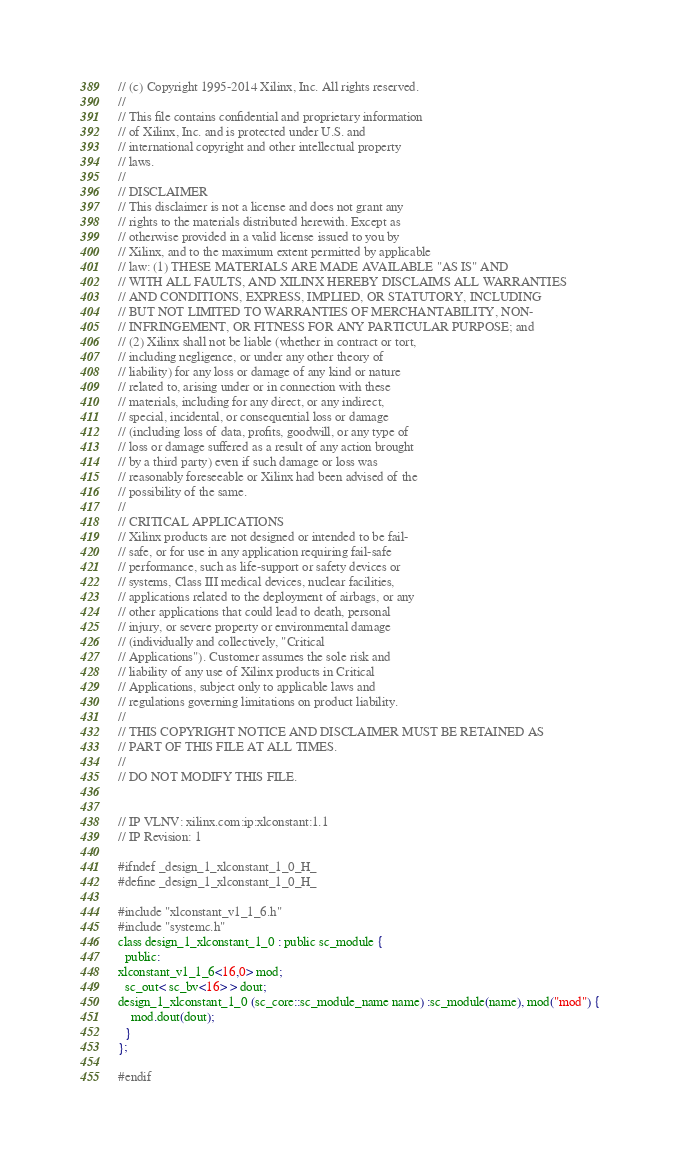<code> <loc_0><loc_0><loc_500><loc_500><_C_>// (c) Copyright 1995-2014 Xilinx, Inc. All rights reserved.
// 
// This file contains confidential and proprietary information
// of Xilinx, Inc. and is protected under U.S. and
// international copyright and other intellectual property
// laws.
// 
// DISCLAIMER
// This disclaimer is not a license and does not grant any
// rights to the materials distributed herewith. Except as
// otherwise provided in a valid license issued to you by
// Xilinx, and to the maximum extent permitted by applicable
// law: (1) THESE MATERIALS ARE MADE AVAILABLE "AS IS" AND
// WITH ALL FAULTS, AND XILINX HEREBY DISCLAIMS ALL WARRANTIES
// AND CONDITIONS, EXPRESS, IMPLIED, OR STATUTORY, INCLUDING
// BUT NOT LIMITED TO WARRANTIES OF MERCHANTABILITY, NON-
// INFRINGEMENT, OR FITNESS FOR ANY PARTICULAR PURPOSE; and
// (2) Xilinx shall not be liable (whether in contract or tort,
// including negligence, or under any other theory of
// liability) for any loss or damage of any kind or nature
// related to, arising under or in connection with these
// materials, including for any direct, or any indirect,
// special, incidental, or consequential loss or damage
// (including loss of data, profits, goodwill, or any type of
// loss or damage suffered as a result of any action brought
// by a third party) even if such damage or loss was
// reasonably foreseeable or Xilinx had been advised of the
// possibility of the same.
// 
// CRITICAL APPLICATIONS
// Xilinx products are not designed or intended to be fail-
// safe, or for use in any application requiring fail-safe
// performance, such as life-support or safety devices or
// systems, Class III medical devices, nuclear facilities,
// applications related to the deployment of airbags, or any
// other applications that could lead to death, personal
// injury, or severe property or environmental damage
// (individually and collectively, "Critical
// Applications"). Customer assumes the sole risk and
// liability of any use of Xilinx products in Critical
// Applications, subject only to applicable laws and
// regulations governing limitations on product liability.
// 
// THIS COPYRIGHT NOTICE AND DISCLAIMER MUST BE RETAINED AS
// PART OF THIS FILE AT ALL TIMES.
// 
// DO NOT MODIFY THIS FILE.


// IP VLNV: xilinx.com:ip:xlconstant:1.1
// IP Revision: 1

#ifndef _design_1_xlconstant_1_0_H_
#define _design_1_xlconstant_1_0_H_

#include "xlconstant_v1_1_6.h"
#include "systemc.h"
class design_1_xlconstant_1_0 : public sc_module {
  public:
xlconstant_v1_1_6<16,0> mod;
  sc_out< sc_bv<16> > dout;
design_1_xlconstant_1_0 (sc_core::sc_module_name name) :sc_module(name), mod("mod") {
    mod.dout(dout);
  }
};

#endif
</code> 